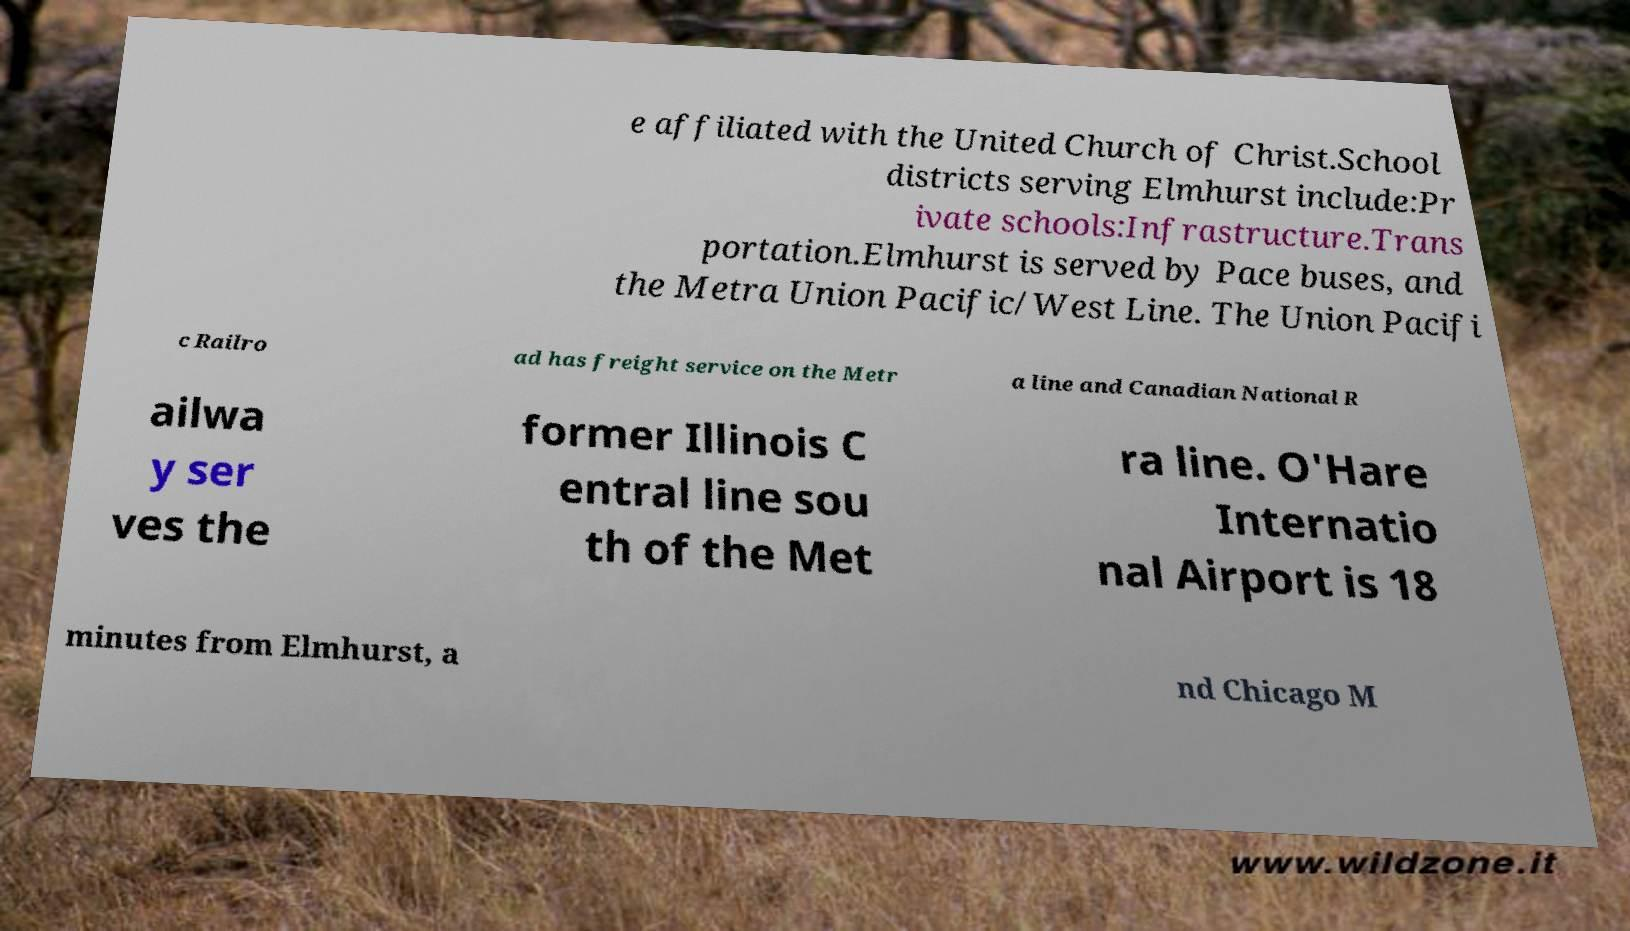There's text embedded in this image that I need extracted. Can you transcribe it verbatim? e affiliated with the United Church of Christ.School districts serving Elmhurst include:Pr ivate schools:Infrastructure.Trans portation.Elmhurst is served by Pace buses, and the Metra Union Pacific/West Line. The Union Pacifi c Railro ad has freight service on the Metr a line and Canadian National R ailwa y ser ves the former Illinois C entral line sou th of the Met ra line. O'Hare Internatio nal Airport is 18 minutes from Elmhurst, a nd Chicago M 